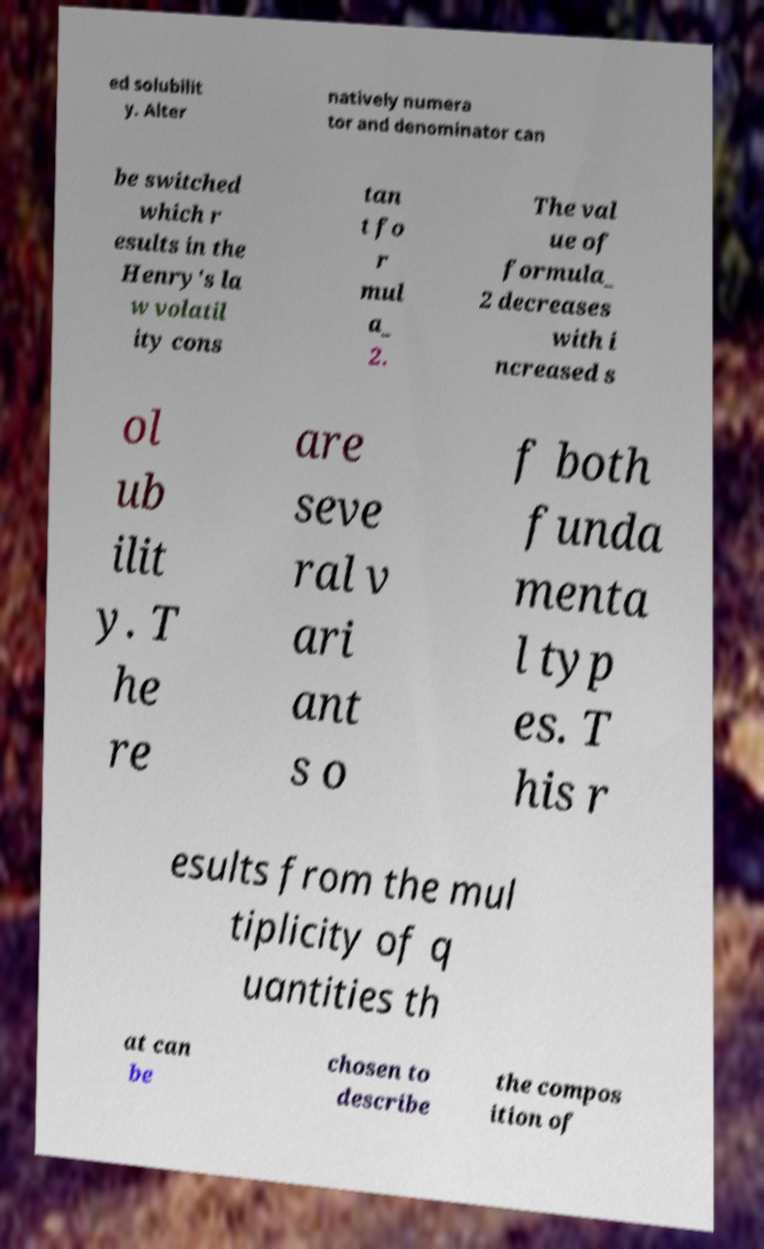Can you read and provide the text displayed in the image?This photo seems to have some interesting text. Can you extract and type it out for me? ed solubilit y. Alter natively numera tor and denominator can be switched which r esults in the Henry's la w volatil ity cons tan t fo r mul a_ 2. The val ue of formula_ 2 decreases with i ncreased s ol ub ilit y. T he re are seve ral v ari ant s o f both funda menta l typ es. T his r esults from the mul tiplicity of q uantities th at can be chosen to describe the compos ition of 